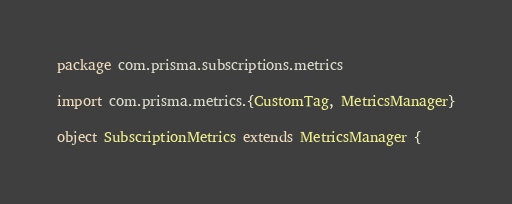Convert code to text. <code><loc_0><loc_0><loc_500><loc_500><_Scala_>package com.prisma.subscriptions.metrics

import com.prisma.metrics.{CustomTag, MetricsManager}

object SubscriptionMetrics extends MetricsManager {</code> 